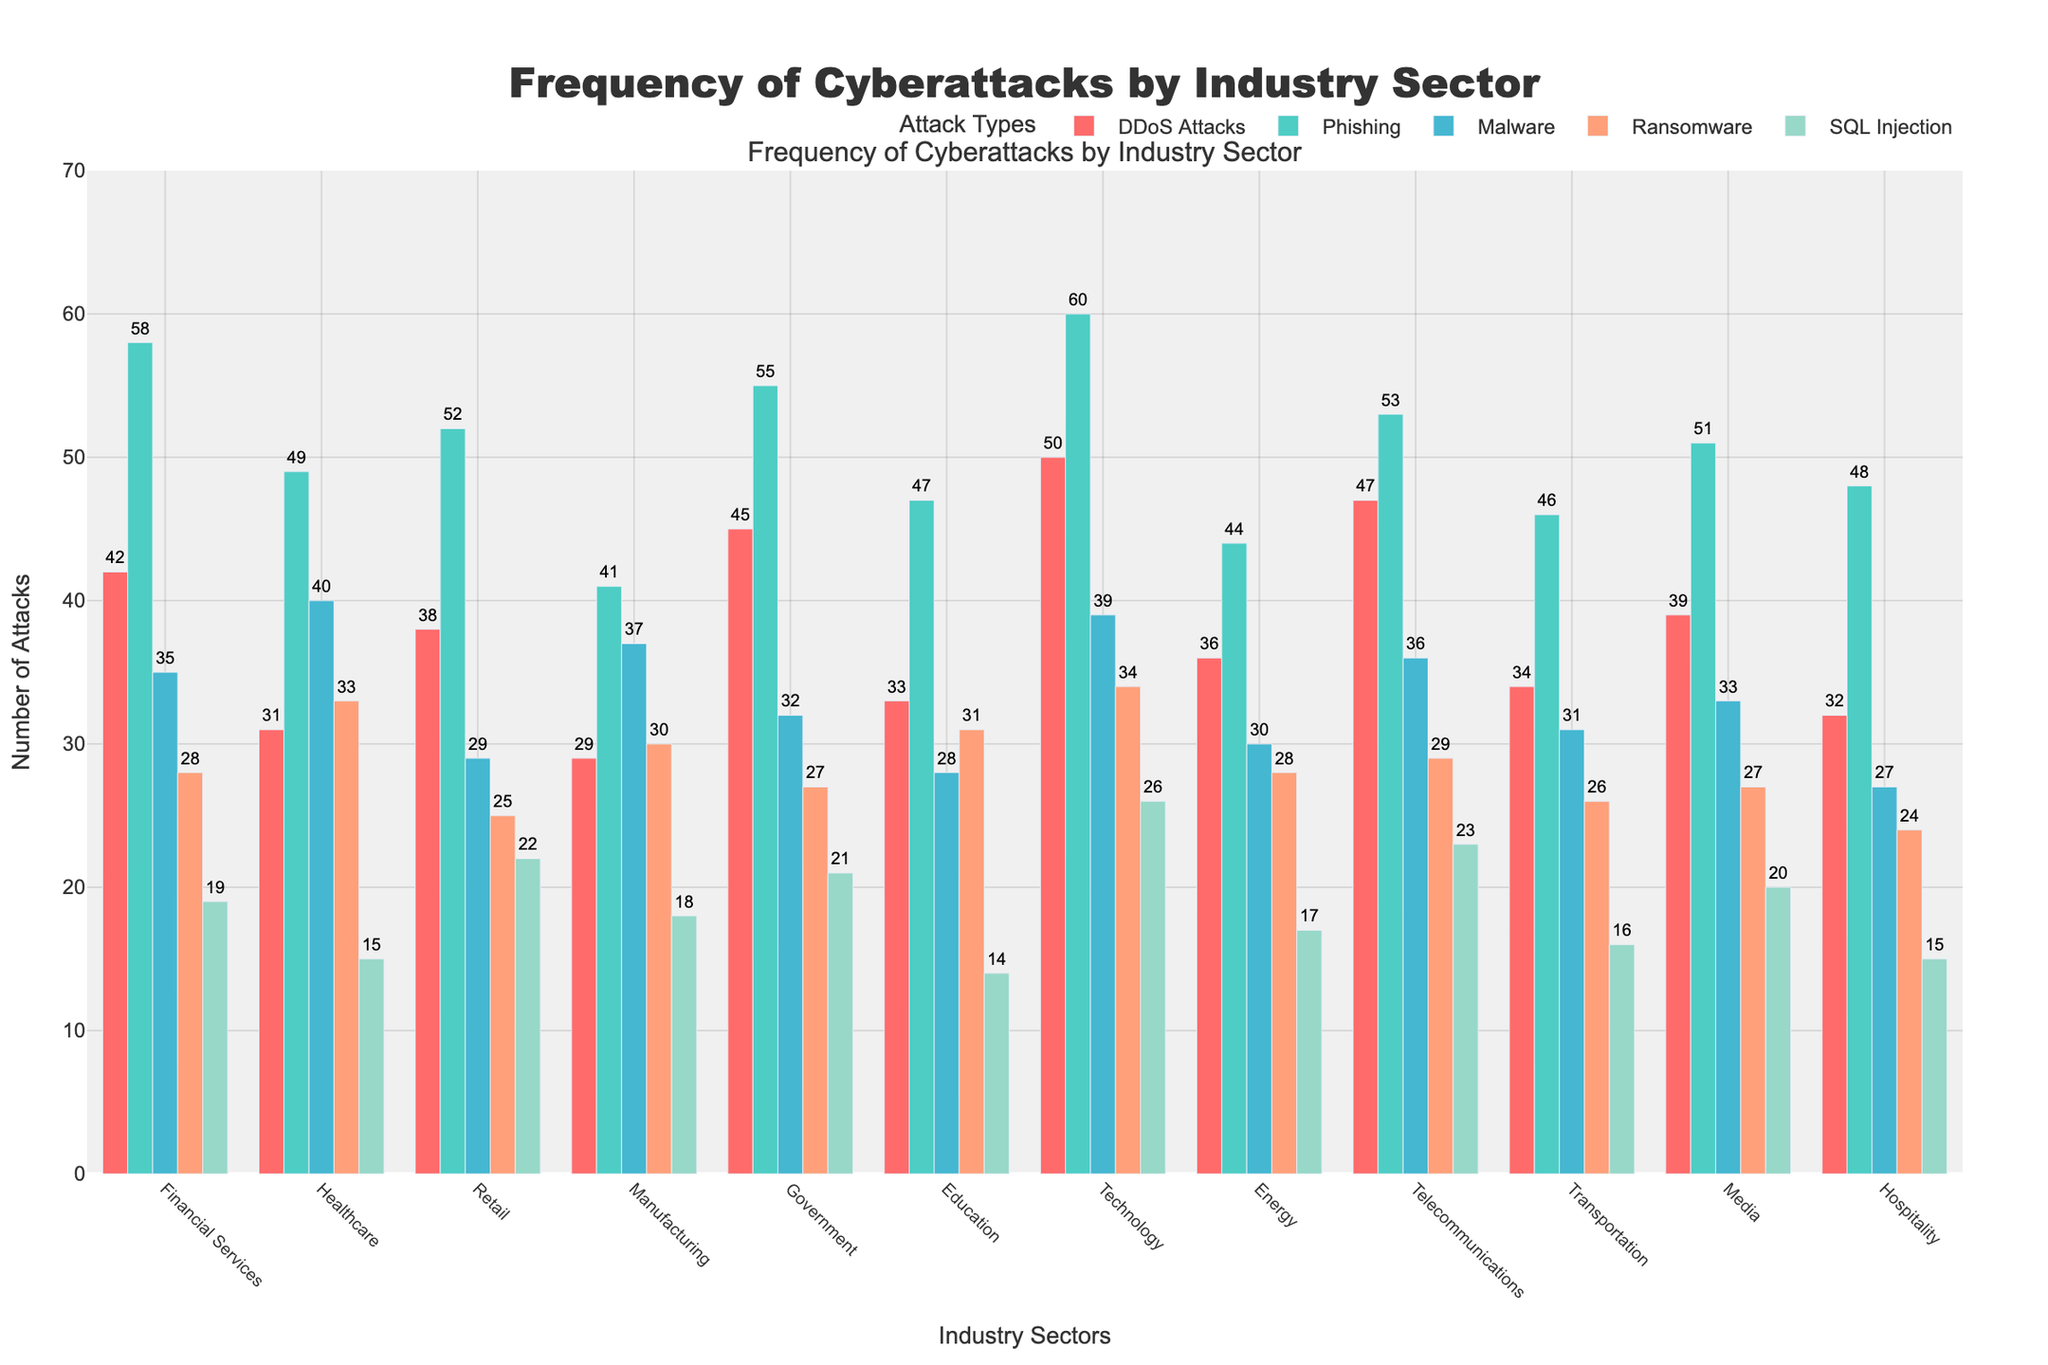Which industry sector experiences the highest frequency of Phishing attacks? The highest bar in the Phishing category is associated with the Technology sector.
Answer: Technology What is the total number of DDoS Attacks across all sectors? Add up the values in the DDoS Attacks column: 42 + 31 + 38 + 29 + 45 + 33 + 50 + 36 + 47 + 34 + 39 + 32 = 456.
Answer: 456 Which two industry sectors have the smallest and largest number of SQL Injection attacks, respectively? The smallest value in the SQL Injection category is Healthcare with 15 attacks, and the largest value is Technology with 26 attacks.
Answer: Healthcare and Technology How many more Malware attacks does the Technology sector experience compared to the Retail sector? Technology has 39 Malware attacks, and Retail has 29 Malware attacks. Therefore, the difference is 39 - 29 = 10.
Answer: 10 Compare the frequency of Ransomware attacks in the Manufacturing and Education sectors. Which sector experiences more? The Manufacturing sector has 30 Ransomware attacks, while the Education sector has 31 Ransomware attacks.
Answer: Education Calculate the average number of Phishing attacks across the Financial Services, Government, and Media sectors. Sum the number of Phishing attacks in these sectors: 58 + 55 + 51 = 164. Then, divide by 3 to get the average: 164 / 3 ≈ 54.67.
Answer: 54.67 Identify the industry sector that has the most even distribution of attack types. The Healthcare sector shows the most balanced distribution with values of 31, 49, 40, 33, 15, which show a relatively small variance.
Answer: Healthcare What is the difference in the number of DDoS Attacks between the highest and lowest reporting sectors? The highest number of DDoS Attacks is in the Technology sector with 50, and the lowest is the Manufacturing sector with 29. Therefore, the difference is 50 - 29 = 21.
Answer: 21 Which industry sector has the highest combined total of Ransomware and SQL Injection attacks? Add the values for each sector and compare. The Technology sector has the highest combined total of 34 (Ransomware) + 26 (SQL Injection) = 60.
Answer: Technology 